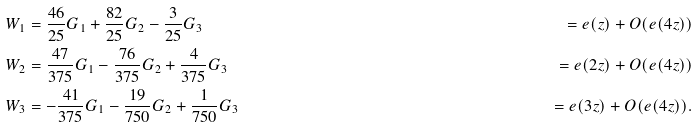Convert formula to latex. <formula><loc_0><loc_0><loc_500><loc_500>W _ { 1 } & = \frac { 4 6 } { 2 5 } G _ { 1 } + \frac { 8 2 } { 2 5 } G _ { 2 } - \frac { 3 } { 2 5 } G _ { 3 } & = e ( z ) + O ( e ( 4 z ) ) \\ W _ { 2 } & = \frac { 4 7 } { 3 7 5 } G _ { 1 } - \frac { 7 6 } { 3 7 5 } G _ { 2 } + \frac { 4 } { 3 7 5 } G _ { 3 } & = e ( 2 z ) + O ( e ( 4 z ) ) \\ W _ { 3 } & = - \frac { 4 1 } { 3 7 5 } G _ { 1 } - \frac { 1 9 } { 7 5 0 } G _ { 2 } + \frac { 1 } { 7 5 0 } G _ { 3 } & = e ( 3 z ) + O ( e ( 4 z ) ) .</formula> 